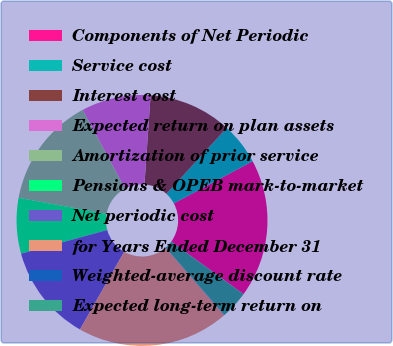Convert chart. <chart><loc_0><loc_0><loc_500><loc_500><pie_chart><fcel>Components of Net Periodic<fcel>Service cost<fcel>Interest cost<fcel>Expected return on plan assets<fcel>Amortization of prior service<fcel>Pensions & OPEB mark-to-market<fcel>Net periodic cost<fcel>for Years Ended December 31<fcel>Weighted-average discount rate<fcel>Expected long-term return on<nl><fcel>17.82%<fcel>5.38%<fcel>10.71%<fcel>8.93%<fcel>14.27%<fcel>7.16%<fcel>12.49%<fcel>19.6%<fcel>0.04%<fcel>3.6%<nl></chart> 